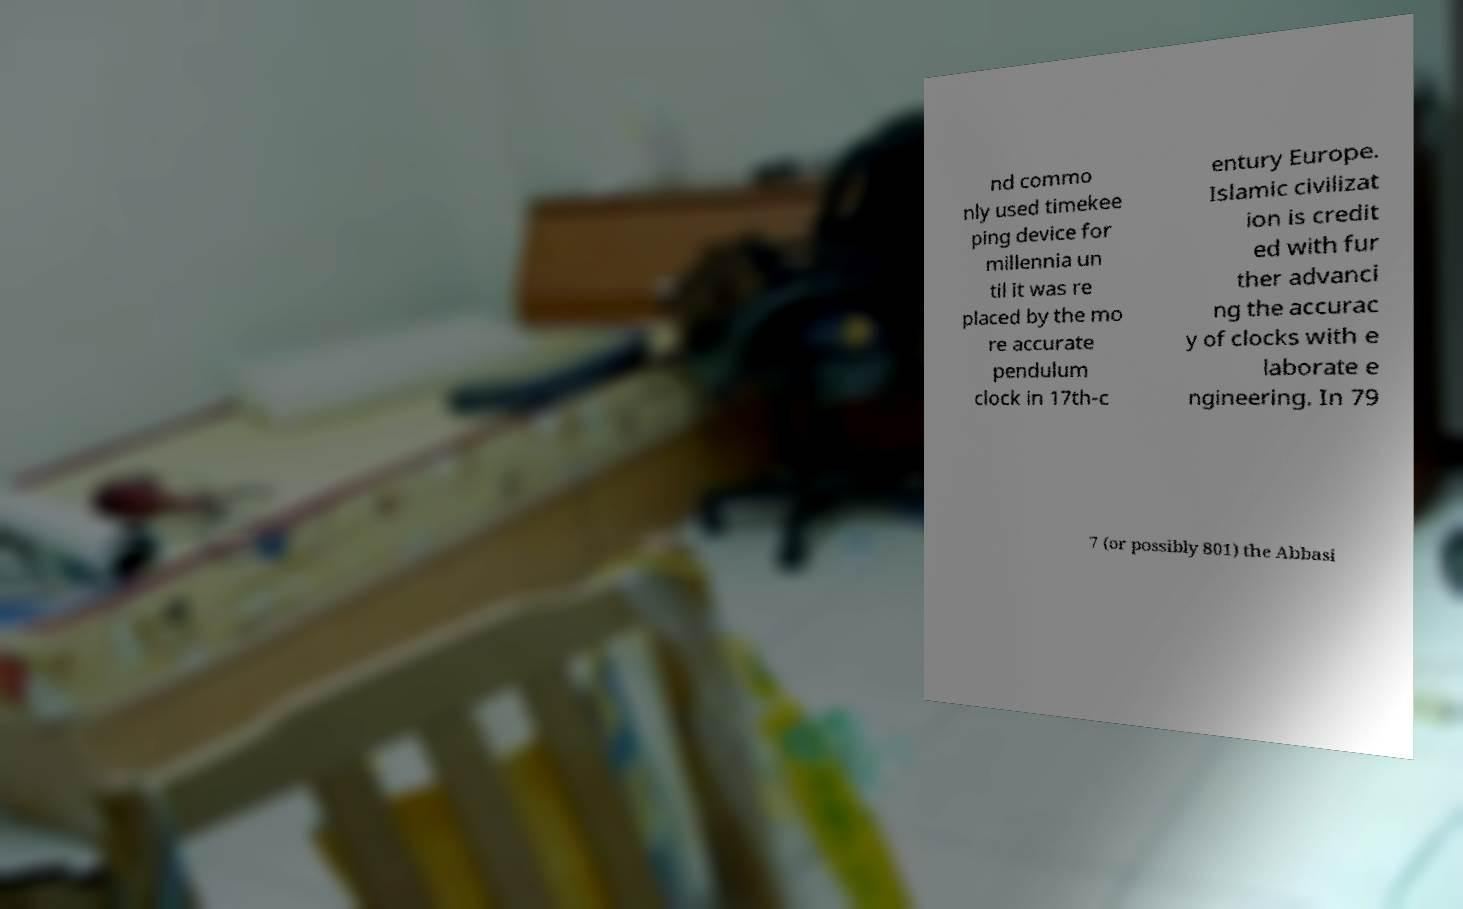Could you assist in decoding the text presented in this image and type it out clearly? nd commo nly used timekee ping device for millennia un til it was re placed by the mo re accurate pendulum clock in 17th-c entury Europe. Islamic civilizat ion is credit ed with fur ther advanci ng the accurac y of clocks with e laborate e ngineering. In 79 7 (or possibly 801) the Abbasi 